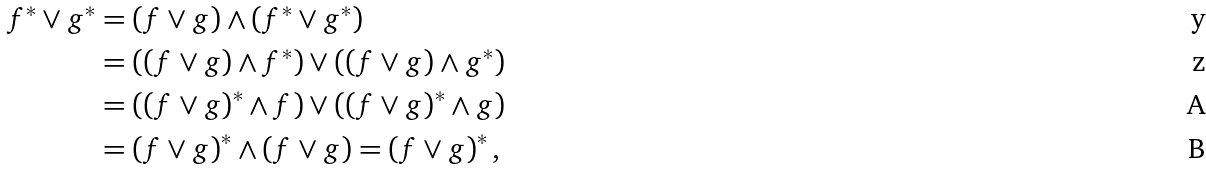Convert formula to latex. <formula><loc_0><loc_0><loc_500><loc_500>f ^ { \ast } \vee g ^ { \ast } & = \left ( f \vee g \right ) \wedge \left ( f ^ { \ast } \vee g ^ { \ast } \right ) \\ & = \left ( \left ( f \vee g \right ) \wedge f ^ { \ast } \right ) \vee \left ( \left ( f \vee g \right ) \wedge g ^ { \ast } \right ) \\ & = \left ( \left ( f \vee g \right ) ^ { \ast } \wedge f \right ) \vee \left ( \left ( f \vee g \right ) ^ { \ast } \wedge g \right ) \\ & = \left ( f \vee g \right ) ^ { \ast } \wedge \left ( f \vee g \right ) = \left ( f \vee g \right ) ^ { \ast } ,</formula> 